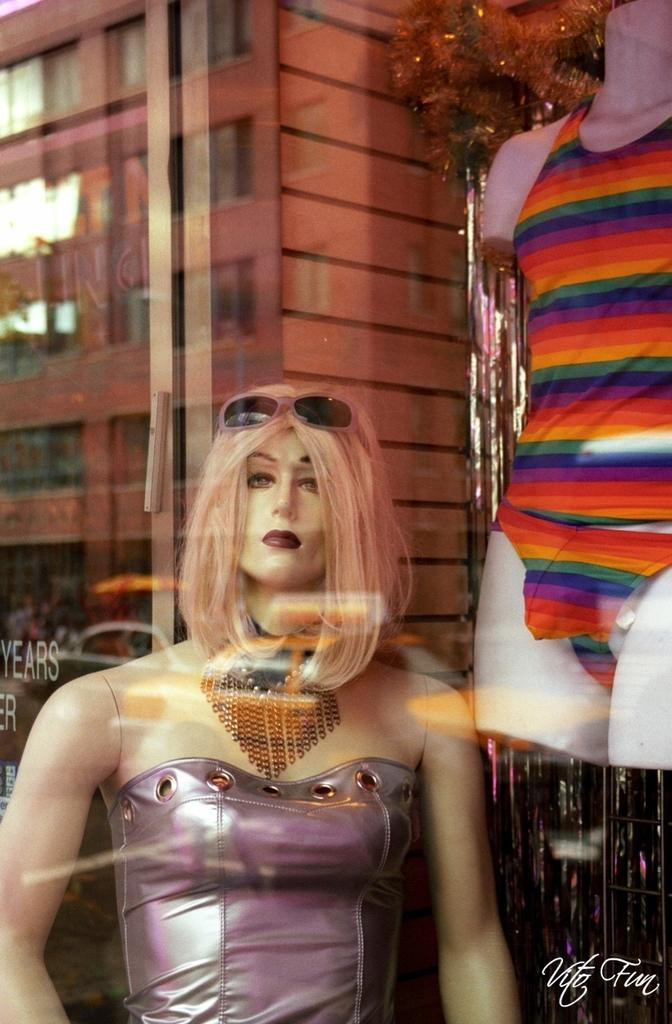What is the main subject in the image? There is a mannequin in the image. What accessory can be seen on the mannequin? There are glasses in the image. What can be seen in the distance behind the mannequin? There is a building visible in the background of the image. How many toes can be seen on the mannequin's feet in the image? There are no feet or toes visible on the mannequin in the image. 